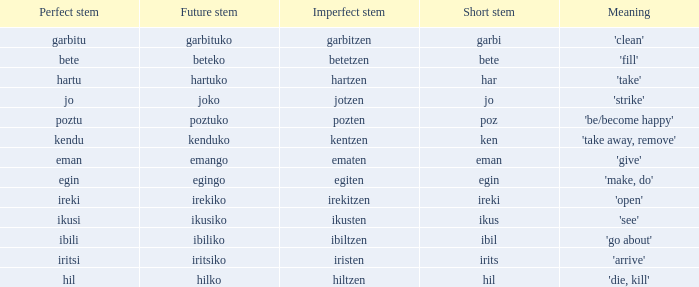What is the short stem for garbitzen? Garbi. Write the full table. {'header': ['Perfect stem', 'Future stem', 'Imperfect stem', 'Short stem', 'Meaning'], 'rows': [['garbitu', 'garbituko', 'garbitzen', 'garbi', "'clean'"], ['bete', 'beteko', 'betetzen', 'bete', "'fill'"], ['hartu', 'hartuko', 'hartzen', 'har', "'take'"], ['jo', 'joko', 'jotzen', 'jo', "'strike'"], ['poztu', 'poztuko', 'pozten', 'poz', "'be/become happy'"], ['kendu', 'kenduko', 'kentzen', 'ken', "'take away, remove'"], ['eman', 'emango', 'ematen', 'eman', "'give'"], ['egin', 'egingo', 'egiten', 'egin', "'make, do'"], ['ireki', 'irekiko', 'irekitzen', 'ireki', "'open'"], ['ikusi', 'ikusiko', 'ikusten', 'ikus', "'see'"], ['ibili', 'ibiliko', 'ibiltzen', 'ibil', "'go about'"], ['iritsi', 'iritsiko', 'iristen', 'irits', "'arrive'"], ['hil', 'hilko', 'hiltzen', 'hil', "'die, kill'"]]} 